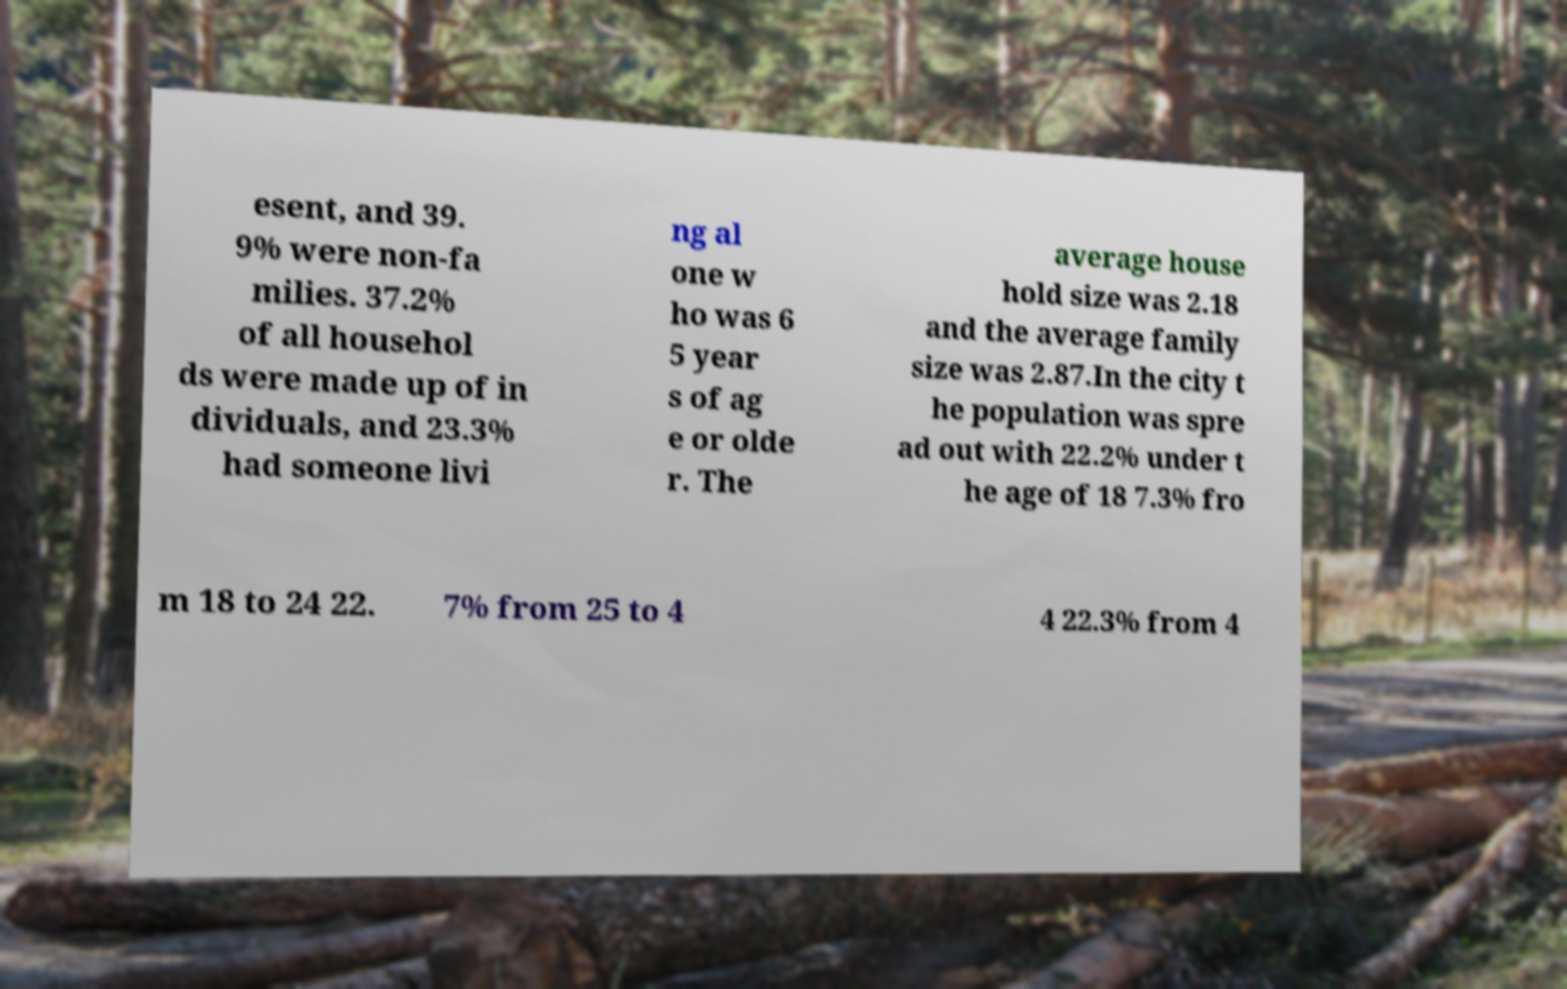Can you read and provide the text displayed in the image?This photo seems to have some interesting text. Can you extract and type it out for me? esent, and 39. 9% were non-fa milies. 37.2% of all househol ds were made up of in dividuals, and 23.3% had someone livi ng al one w ho was 6 5 year s of ag e or olde r. The average house hold size was 2.18 and the average family size was 2.87.In the city t he population was spre ad out with 22.2% under t he age of 18 7.3% fro m 18 to 24 22. 7% from 25 to 4 4 22.3% from 4 